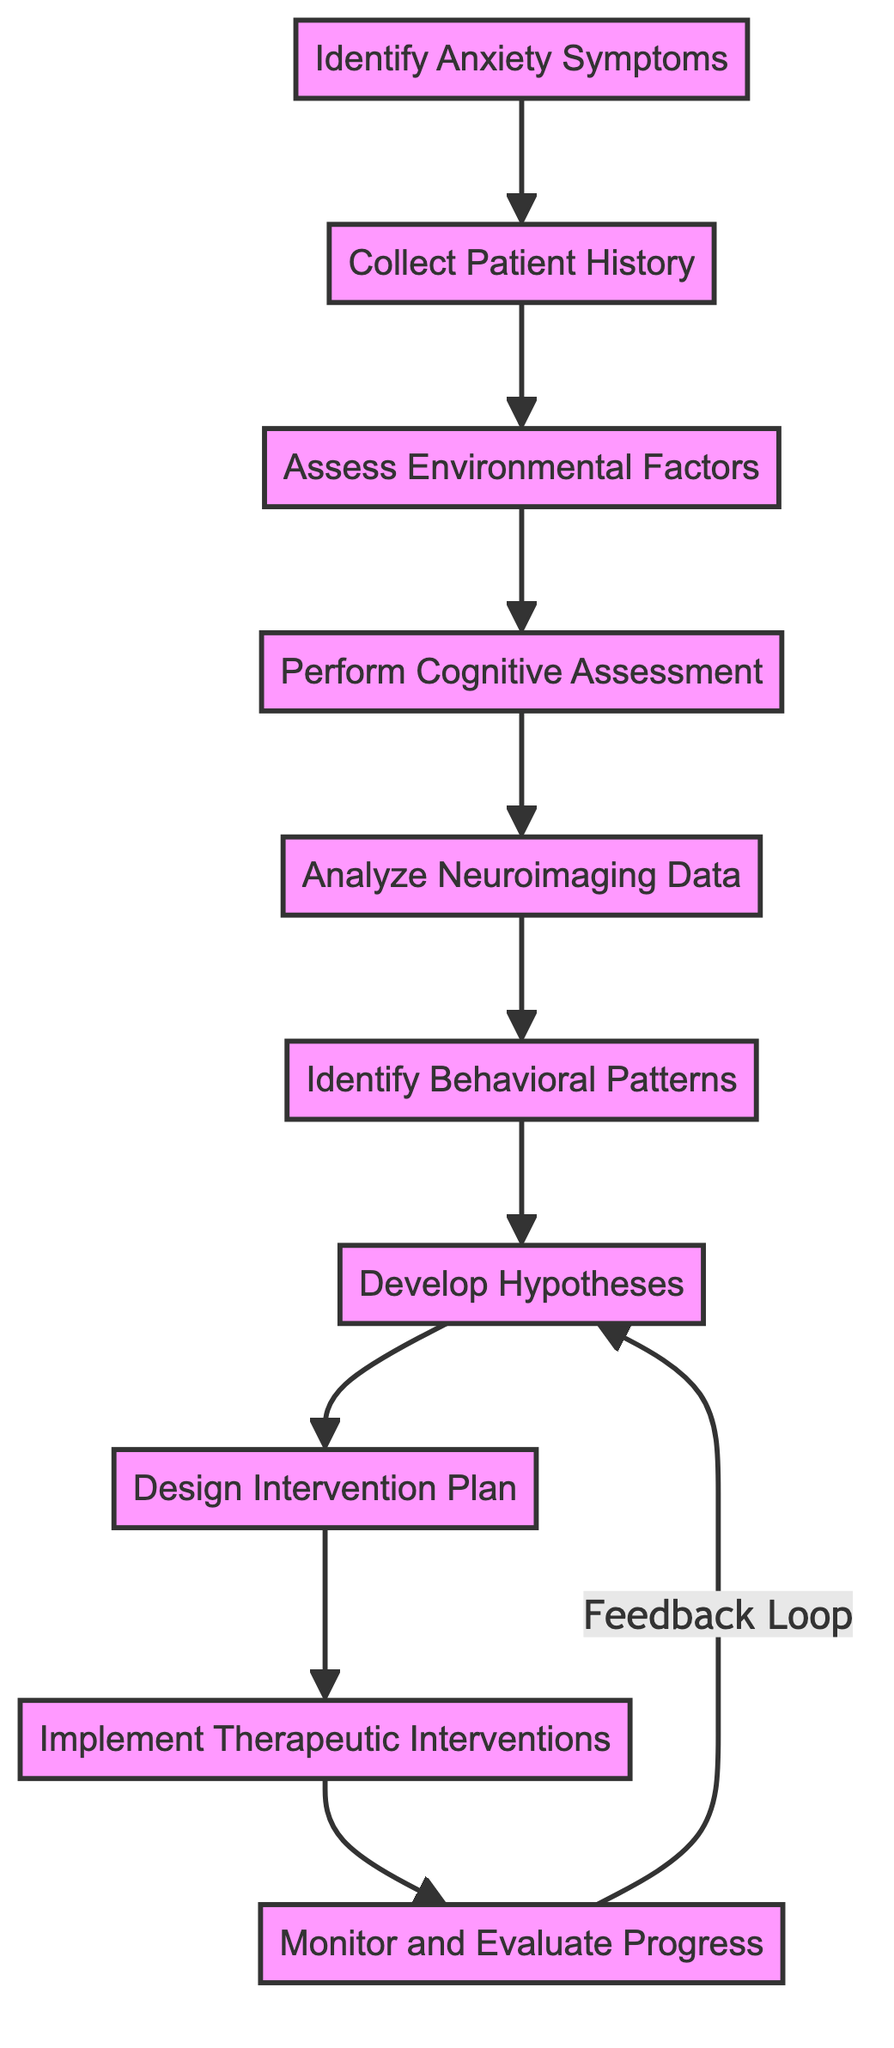What is the first step in the flowchart? The flowchart starts with "Identify Anxiety Symptoms," which is the first process listed.
Answer: Identify Anxiety Symptoms How many total processes are in this flowchart? There are ten distinct processes represented in the flowchart according to the listed elements.
Answer: 10 Which process follows "Collect Patient History"? The next step after "Collect Patient History" is "Assess Environmental Factors," which is indicated by the directional arrow leading out from the second process.
Answer: Assess Environmental Factors What does the node "Analyze Neuroimaging Data" analyze? This step focuses on interpreting MRI or fMRI scans to identify abnormalities in specific brain regions associated with anxiety.
Answer: MRI or fMRI scans Which node receives feedback from "Monitor and Evaluate Progress"? The feedback loop returns to "Develop Hypotheses" as indicated by the arrow connecting these two processes.
Answer: Develop Hypotheses Which processes are involved in treatment planning? The processes "Design Intervention Plan" and "Implement Therapeutic Interventions" are directly related to the creation and application of the treatment strategies.
Answer: Design Intervention Plan, Implement Therapeutic Interventions What is the last process in this flowchart? The final process in the flowchart is "Monitor and Evaluate Progress," representing the concluding stage of the function.
Answer: Monitor and Evaluate Progress What are the outcomes monitored in the last stage? The last stage involves reviewing the patient's progress and adjusting the intervention plan as necessary to achieve better outcomes.
Answer: Patient's progress How do behavioral patterns fit into the assessment process? "Identify Behavioral Patterns" occurs after analyzing neuroimaging data and is influenced by previous assessments to observe behaviors that may trigger anxiety.
Answer: Following neuroimaging data analysis What does the process "Perform Cognitive Assessment" measure? It measures cognitive functions such as memory, attention, and executive functioning through standardized tests.
Answer: Memory, attention, executive functioning 